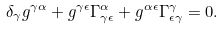Convert formula to latex. <formula><loc_0><loc_0><loc_500><loc_500>\delta _ { \gamma } g ^ { \gamma \alpha } + g ^ { \gamma \epsilon } \Gamma ^ { \alpha } _ { \gamma \epsilon } + g ^ { \alpha \epsilon } \Gamma ^ { \gamma } _ { \epsilon \gamma } = 0 .</formula> 